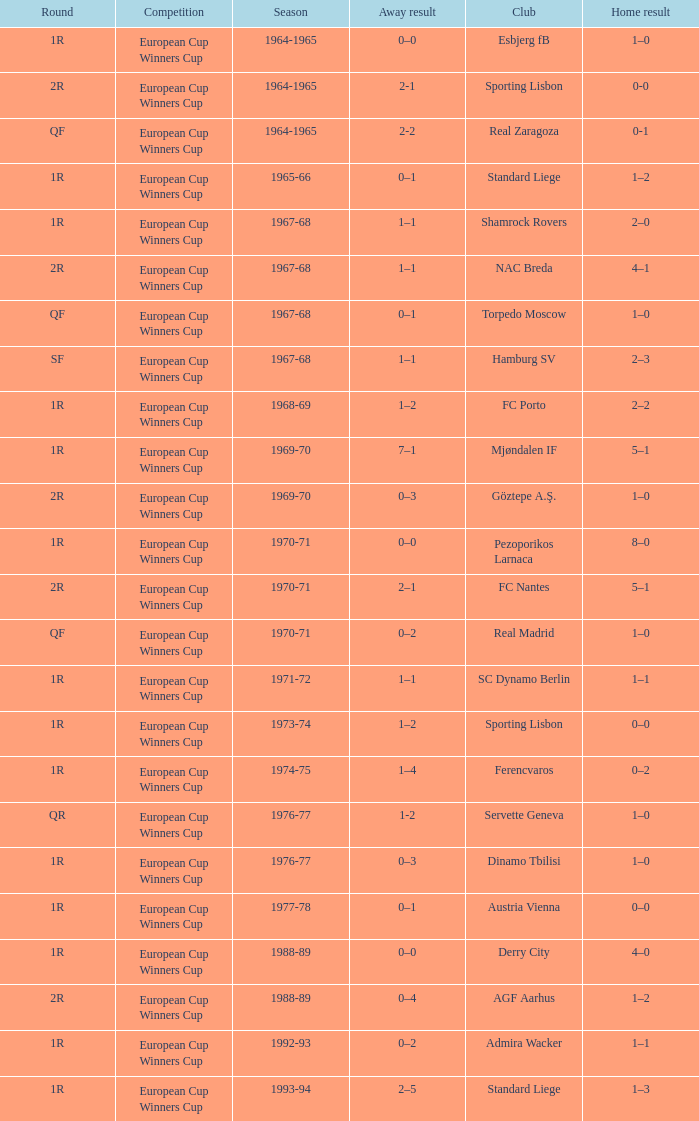Away result of 1–1, and a Round of 1r, and a Season of 1967-68 involves what club? Shamrock Rovers. 